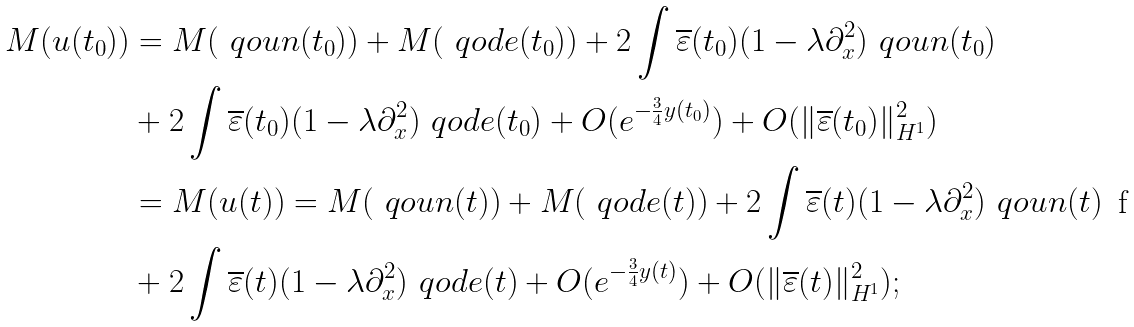<formula> <loc_0><loc_0><loc_500><loc_500>M ( u ( t _ { 0 } ) ) & = M ( \ q o u n ( t _ { 0 } ) ) + M ( \ q o d e ( t _ { 0 } ) ) + 2 \int \overline { \varepsilon } ( t _ { 0 } ) ( 1 - \lambda \partial _ { x } ^ { 2 } ) \ q o u n ( t _ { 0 } ) \\ & + 2 \int \overline { \varepsilon } ( t _ { 0 } ) ( 1 - \lambda \partial _ { x } ^ { 2 } ) \ q o d e ( t _ { 0 } ) + O ( e ^ { - \frac { 3 } { 4 } y ( t _ { 0 } ) } ) + O ( \| \overline { \varepsilon } ( t _ { 0 } ) \| ^ { 2 } _ { H ^ { 1 } } ) \\ & = M ( u ( t ) ) = M ( \ q o u n ( t ) ) + M ( \ q o d e ( t ) ) + 2 \int \overline { \varepsilon } ( t ) ( 1 - \lambda \partial _ { x } ^ { 2 } ) \ q o u n ( t ) \\ & + 2 \int \overline { \varepsilon } ( t ) ( 1 - \lambda \partial _ { x } ^ { 2 } ) \ q o d e ( t ) + O ( e ^ { - \frac { 3 } { 4 } y ( t ) } ) + O ( \| \overline { \varepsilon } ( t ) \| ^ { 2 } _ { H ^ { 1 } } ) ;</formula> 